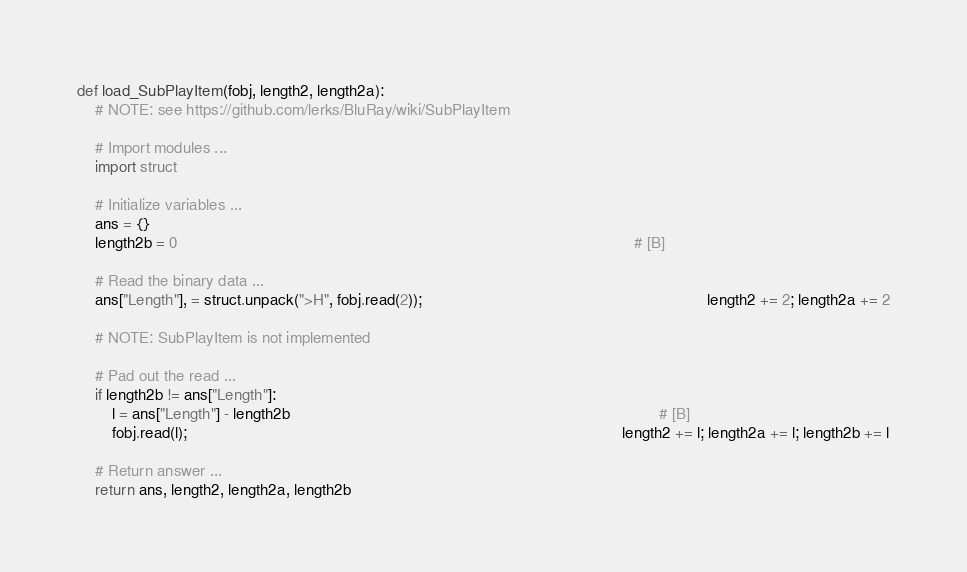Convert code to text. <code><loc_0><loc_0><loc_500><loc_500><_Python_>def load_SubPlayItem(fobj, length2, length2a):
    # NOTE: see https://github.com/lerks/BluRay/wiki/SubPlayItem

    # Import modules ...
    import struct

    # Initialize variables ...
    ans = {}
    length2b = 0                                                                                                        # [B]

    # Read the binary data ...
    ans["Length"], = struct.unpack(">H", fobj.read(2));                                                                 length2 += 2; length2a += 2

    # NOTE: SubPlayItem is not implemented

    # Pad out the read ...
    if length2b != ans["Length"]:
        l = ans["Length"] - length2b                                                                                    # [B]
        fobj.read(l);                                                                                                   length2 += l; length2a += l; length2b += l

    # Return answer ...
    return ans, length2, length2a, length2b
</code> 